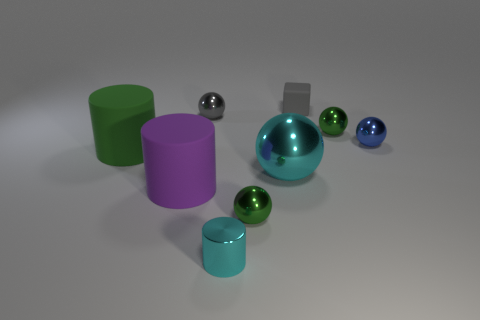What number of cyan things are either small cylinders or tiny matte spheres?
Your answer should be compact. 1. The big ball has what color?
Offer a very short reply. Cyan. Is the number of tiny gray cubes in front of the block less than the number of big cyan metal balls that are in front of the gray metallic object?
Your answer should be compact. Yes. There is a big object that is left of the tiny metal cylinder and to the right of the large green matte cylinder; what shape is it?
Your response must be concise. Cylinder. What number of other purple objects are the same shape as the small matte object?
Your response must be concise. 0. There is a green cylinder that is made of the same material as the purple cylinder; what size is it?
Provide a succinct answer. Large. What number of brown matte cubes have the same size as the metallic cylinder?
Provide a succinct answer. 0. There is a cylinder that is the same color as the large shiny object; what is its size?
Your answer should be very brief. Small. What is the color of the big object to the right of the big matte cylinder that is in front of the green rubber thing?
Give a very brief answer. Cyan. Is there a large cylinder of the same color as the tiny cylinder?
Make the answer very short. No. 